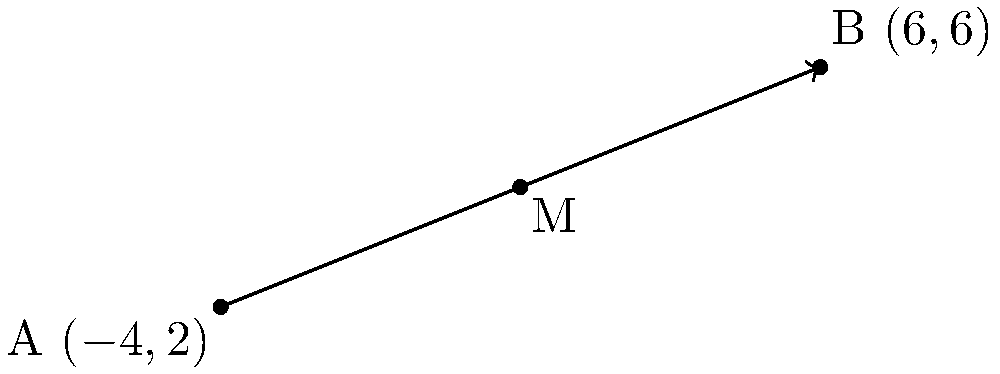As you're developing your e-commerce website using CakePHP, you need to implement a feature that calculates the midpoint between two product locations in your warehouse. Given the coordinates of two endpoints A$(-4,2)$ and B$(6,6)$, find the coordinates of the midpoint M. To find the midpoint M of a line segment AB, we use the midpoint formula:

$$M = (\frac{x_1 + x_2}{2}, \frac{y_1 + y_2}{2})$$

Where $(x_1, y_1)$ are the coordinates of point A and $(x_2, y_2)$ are the coordinates of point B.

Step 1: Identify the coordinates
A$(-4,2)$, so $x_1 = -4$ and $y_1 = 2$
B$(6,6)$, so $x_2 = 6$ and $y_2 = 6$

Step 2: Calculate the x-coordinate of the midpoint
$$x_M = \frac{x_1 + x_2}{2} = \frac{-4 + 6}{2} = \frac{2}{2} = 1$$

Step 3: Calculate the y-coordinate of the midpoint
$$y_M = \frac{y_1 + y_2}{2} = \frac{2 + 6}{2} = \frac{8}{2} = 4$$

Step 4: Combine the results
The midpoint M has coordinates $(x_M, y_M) = (1, 4)$
Answer: $(1,4)$ 